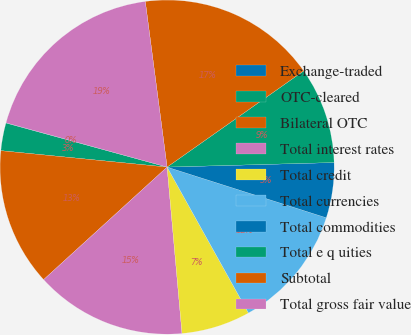Convert chart to OTSL. <chart><loc_0><loc_0><loc_500><loc_500><pie_chart><fcel>Exchange-traded<fcel>OTC-cleared<fcel>Bilateral OTC<fcel>Total interest rates<fcel>Total credit<fcel>Total currencies<fcel>Total commodities<fcel>Total e q uities<fcel>Subtotal<fcel>Total gross fair value<nl><fcel>0.02%<fcel>2.68%<fcel>13.33%<fcel>14.66%<fcel>6.67%<fcel>12.0%<fcel>5.34%<fcel>9.33%<fcel>17.32%<fcel>18.65%<nl></chart> 